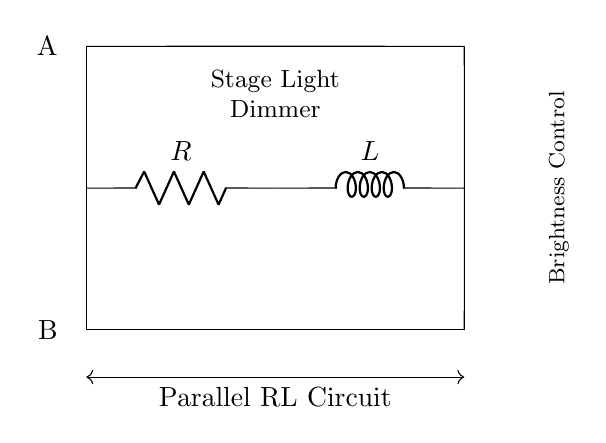What components are present in the circuit? The circuit diagram shows a resistor and an inductor connected in parallel. These are essential components for controlling the brightness of stage lighting.
Answer: Resistor and Inductor What is the role of the inductor in this circuit? The inductor in the circuit helps to smooth out the current flow and manage the reactive power, which is vital in dimming applications for lighting.
Answer: Smooth current flow How are the resistor and inductor connected? In the circuit, the resistor and inductor are connected in parallel, meaning they share the same voltage across their terminals while allowing different current paths.
Answer: Parallel What does the "Brightness Control" label indicate? The "Brightness Control" label indicates that the circuit is designed to regulate the brightness of stage lights by manipulating the voltage or current through the resistor and inductor.
Answer: Regulate brightness What would happen if you increase the resistance in the circuit? Increasing the resistance would decrease the current flowing through the circuit, leading to lower brightness of the stage lights, as per Ohm's Law.
Answer: Decrease brightness What is the purpose of using a parallel RL circuit for stage lighting? The parallel RL circuit allows for effective brightness control and ensures that the lights can dim smoothly without flickering or abrupt changes in intensity.
Answer: Smooth dimming 